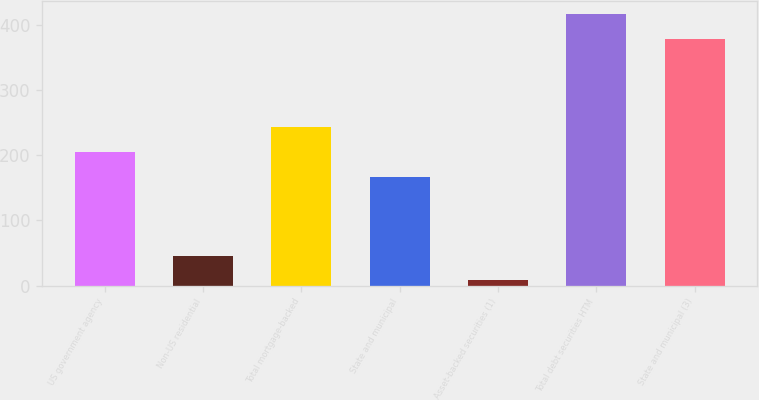Convert chart. <chart><loc_0><loc_0><loc_500><loc_500><bar_chart><fcel>US government agency<fcel>Non-US residential<fcel>Total mortgage-backed<fcel>State and municipal<fcel>Asset-backed securities (1)<fcel>Total debt securities HTM<fcel>State and municipal (3)<nl><fcel>204.8<fcel>45.8<fcel>242.6<fcel>167<fcel>8<fcel>415.8<fcel>378<nl></chart> 